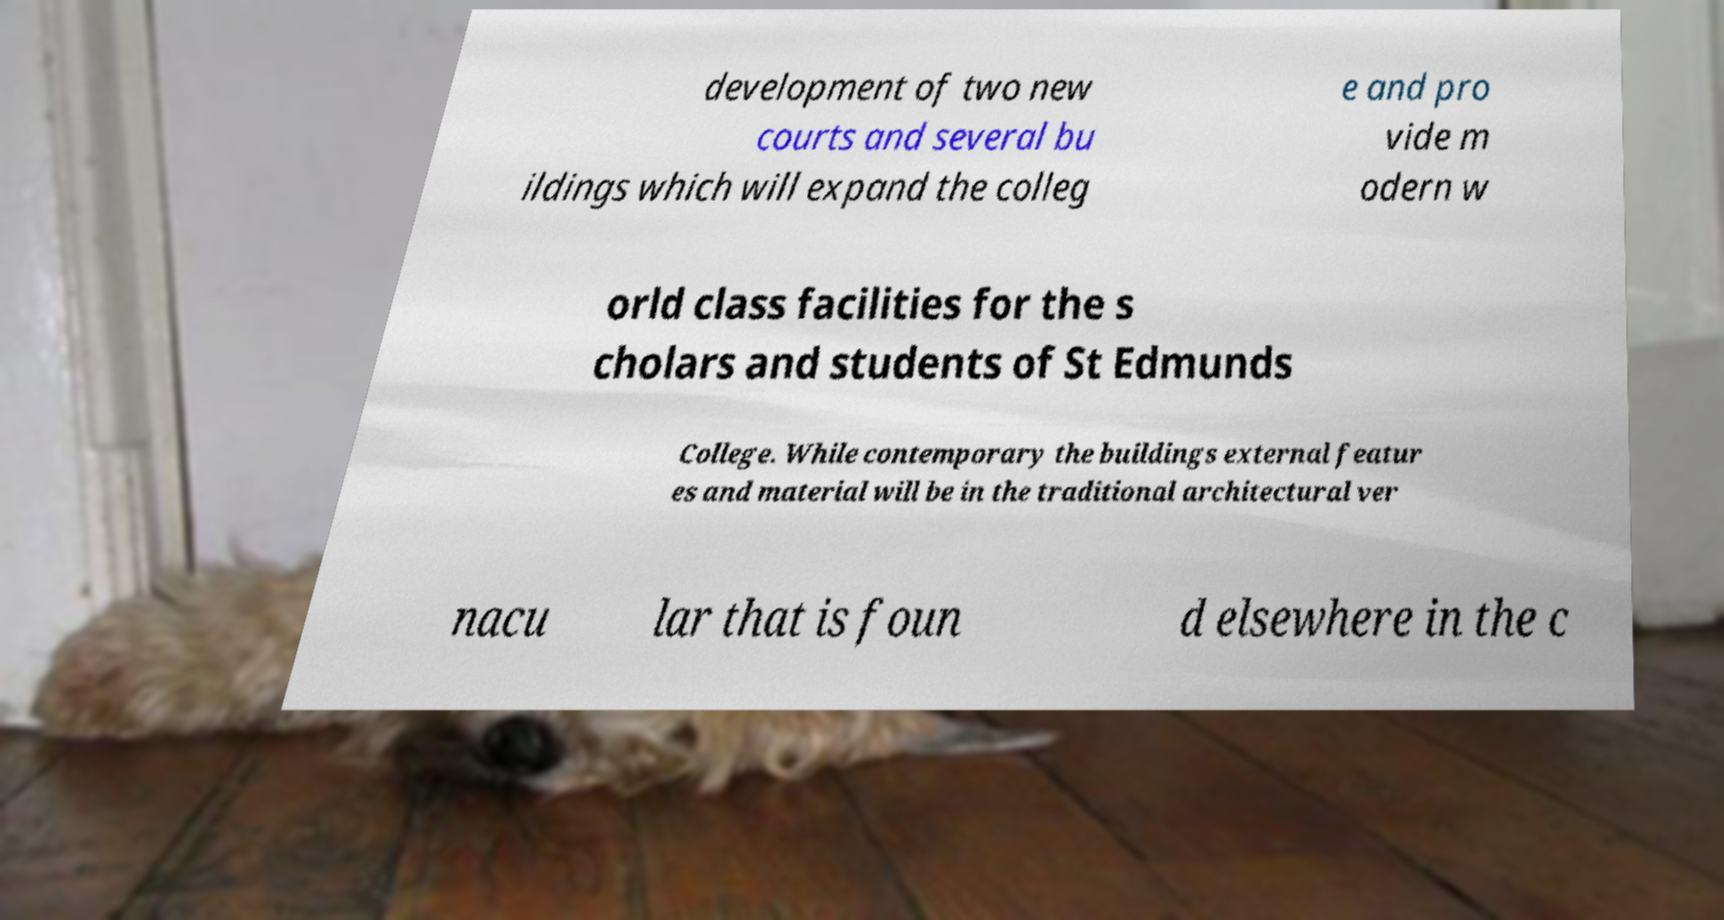Please identify and transcribe the text found in this image. development of two new courts and several bu ildings which will expand the colleg e and pro vide m odern w orld class facilities for the s cholars and students of St Edmunds College. While contemporary the buildings external featur es and material will be in the traditional architectural ver nacu lar that is foun d elsewhere in the c 